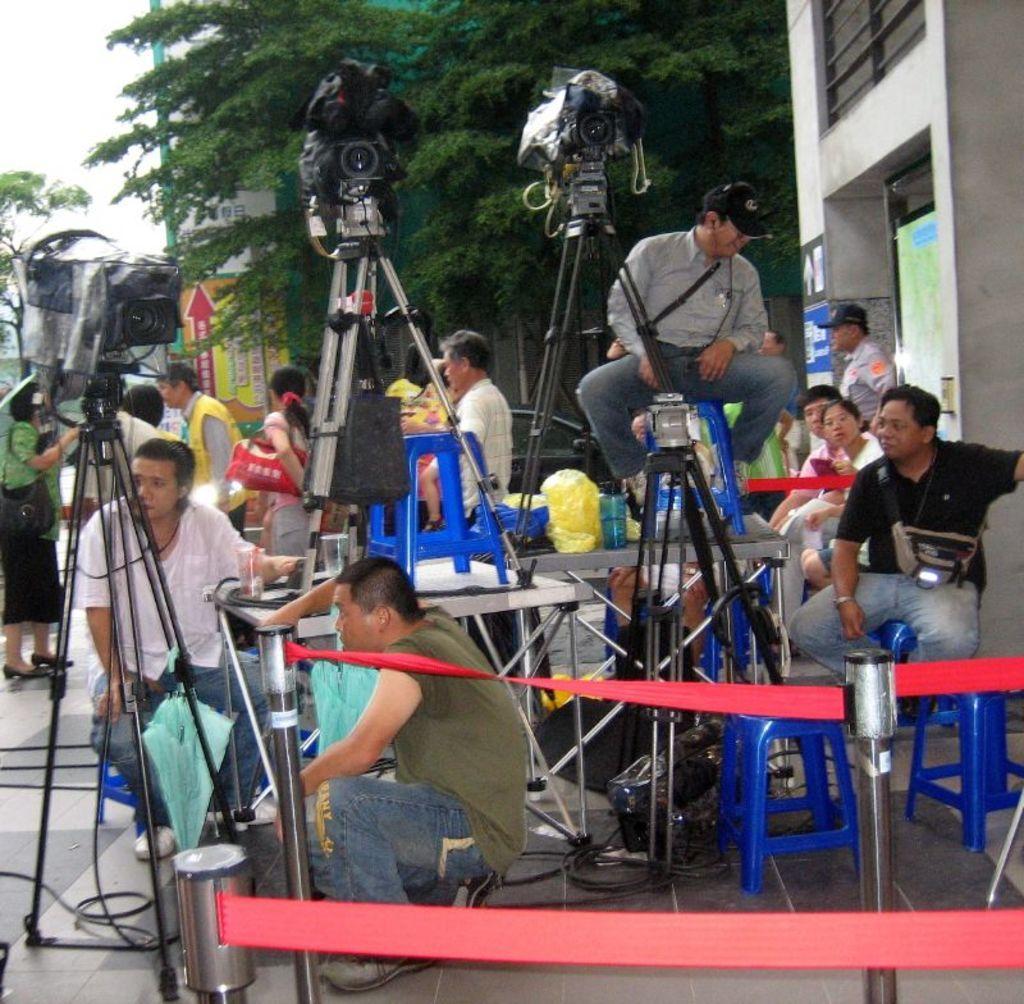How would you summarize this image in a sentence or two? In the image in the center we can see few people were sitting on the stool. And we can see tables,stands,chairs,cameras,dustbin,fence and few other objects. In the background we can see the sky,clouds,trees,buildings,sign boards and few people were standing. 